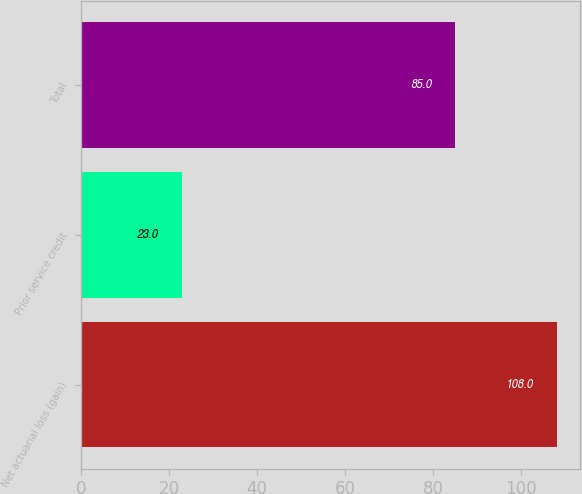Convert chart. <chart><loc_0><loc_0><loc_500><loc_500><bar_chart><fcel>Net actuarial loss (gain)<fcel>Prior service credit<fcel>Total<nl><fcel>108<fcel>23<fcel>85<nl></chart> 